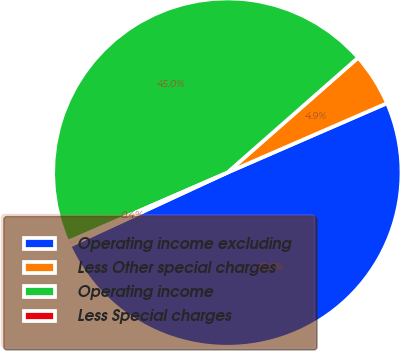Convert chart. <chart><loc_0><loc_0><loc_500><loc_500><pie_chart><fcel>Operating income excluding<fcel>Less Other special charges<fcel>Operating income<fcel>Less Special charges<nl><fcel>49.63%<fcel>4.95%<fcel>45.05%<fcel>0.37%<nl></chart> 